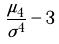Convert formula to latex. <formula><loc_0><loc_0><loc_500><loc_500>\frac { \mu _ { 4 } } { \sigma ^ { 4 } } - 3</formula> 